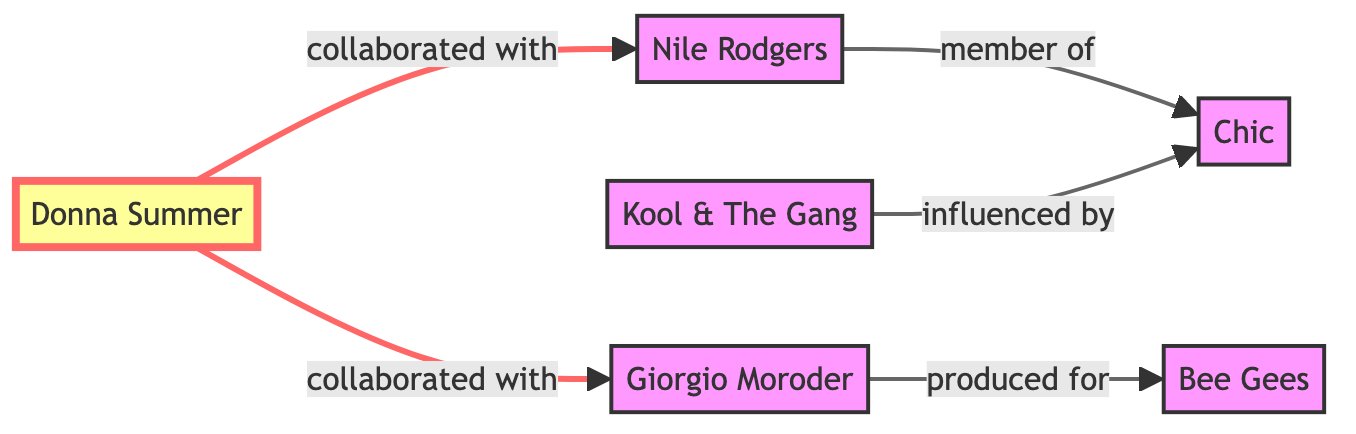What is the relationship between Donna Summer and Giorgio Moroder? The diagram shows an edge labeled "collaborated with" connecting Donna Summer to Giorgio Moroder. This indicates that they have collaborated together in the disco music industry.
Answer: collaborated with How many nodes are in the diagram? By counting the nodes listed in the data, we find six unique artists: Donna Summer, Nile Rodgers, Giorgio Moroder, Chic, Bee Gees, and Kool & The Gang. Therefore, the total number of nodes is six.
Answer: 6 Who is a member of Chic? The diagram indicates that Nile Rodgers is connected to Chic with an edge labeled "member of", signifying that he is a member of this influential disco group.
Answer: Nile Rodgers Which artist has produced for the Bee Gees? The directed edge in the diagram points from Giorgio Moroder to the Bee Gees with the label "produced for", which tells us that Giorgio Moroder produced works for the Bee Gees.
Answer: Giorgio Moroder How are Kool & The Gang and Chic related? The edge labeled "influenced by" connects Kool & The Gang to Chic in the diagram, meaning that Kool & The Gang was influenced by Chic's musical style or contributions.
Answer: influenced by How many collaborations does Donna Summer have shown in the diagram? Donna Summer is connected to two distinct artists (Giorgio Moroder and Nile Rodgers) through edges labeled "collaborated with", thus indicating she has two collaborations represented in the diagram.
Answer: 2 Which artist influenced Kool & The Gang? The diagram indicates that Kool & The Gang is influenced by Chic; this is shown by the directed edge labeled "influenced by" pointing from Kool & The Gang to Chic.
Answer: Chic What can be interpreted about the relationships in this graph? The diagram showcases collaborations and membership related to disco music artists, highlighting how they interconnect through creative partnerships, production, and influence on one another.
Answer: Creative partnerships 